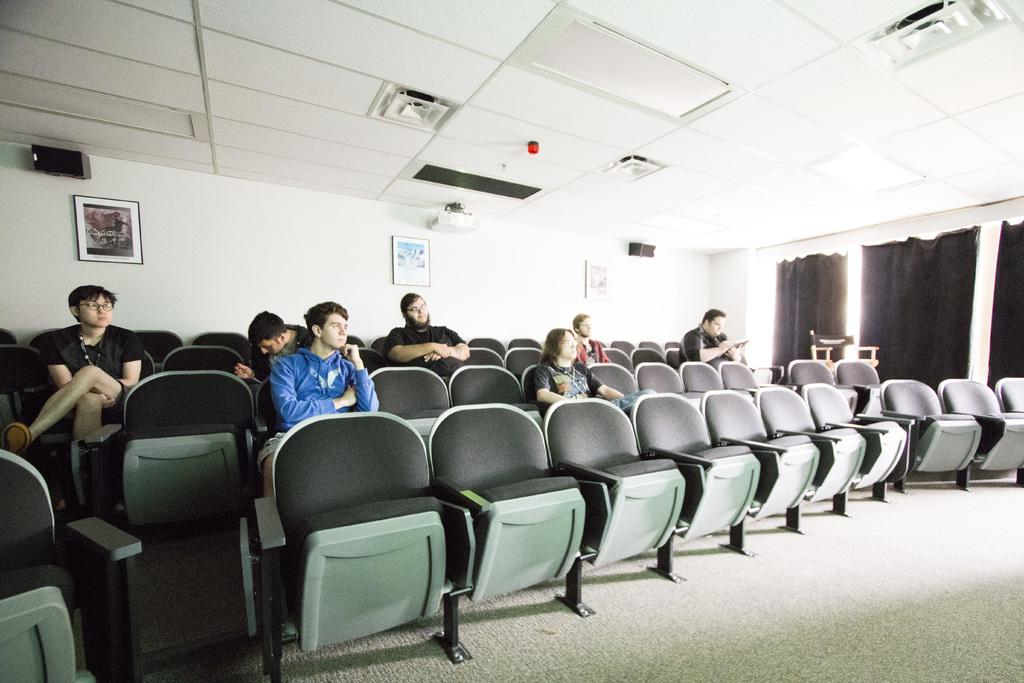How many people are in the image? There is a group of people in the image. What are the people doing in the image? The people are sitting on a chair. Is anyone using a device in the image? Yes, one person is looking at a phone. What other equipment can be seen in the image? There is a projector in the image. What decorations are present on the wall in the image? Phone frames are hung on the wall. How many apples are on the ground in the image? There are no apples present in the image. What is the chance of winning a prize in the image? There is no indication of a prize or a game in the image, so it's not possible to determine the chance of winning a prize. 